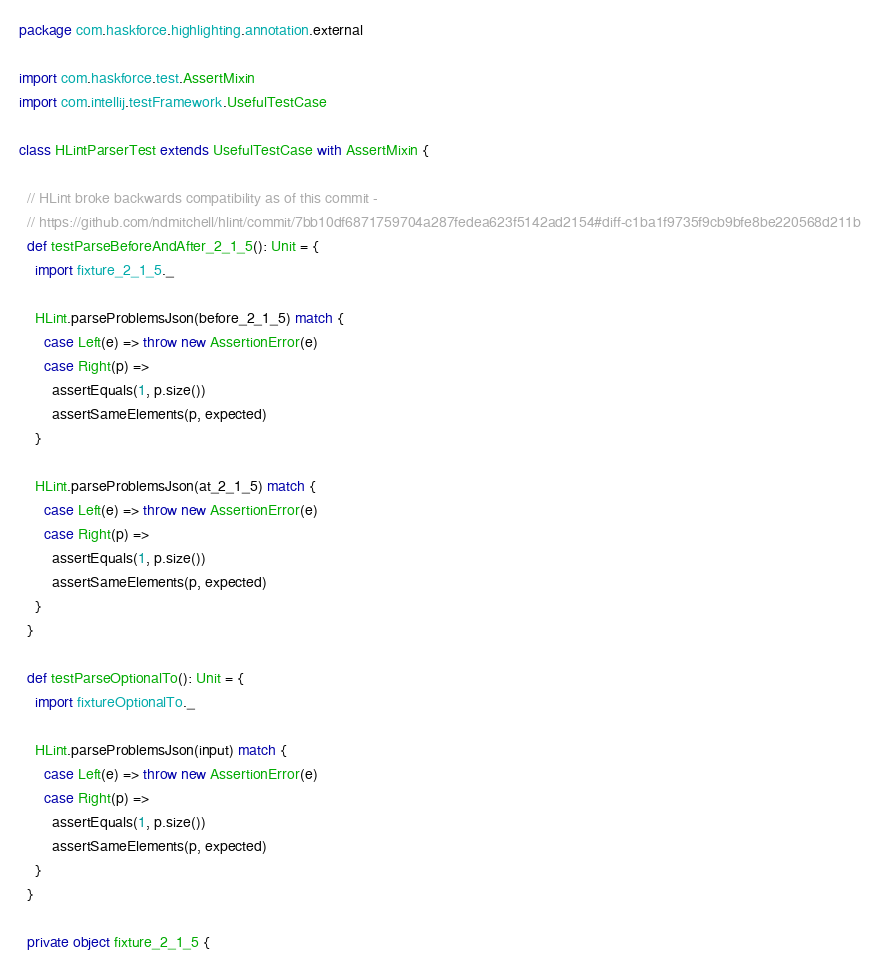<code> <loc_0><loc_0><loc_500><loc_500><_Scala_>package com.haskforce.highlighting.annotation.external

import com.haskforce.test.AssertMixin
import com.intellij.testFramework.UsefulTestCase

class HLintParserTest extends UsefulTestCase with AssertMixin {

  // HLint broke backwards compatibility as of this commit -
  // https://github.com/ndmitchell/hlint/commit/7bb10df6871759704a287fedea623f5142ad2154#diff-c1ba1f9735f9cb9bfe8be220568d211b
  def testParseBeforeAndAfter_2_1_5(): Unit = {
    import fixture_2_1_5._

    HLint.parseProblemsJson(before_2_1_5) match {
      case Left(e) => throw new AssertionError(e)
      case Right(p) =>
        assertEquals(1, p.size())
        assertSameElements(p, expected)
    }

    HLint.parseProblemsJson(at_2_1_5) match {
      case Left(e) => throw new AssertionError(e)
      case Right(p) =>
        assertEquals(1, p.size())
        assertSameElements(p, expected)
    }
  }

  def testParseOptionalTo(): Unit = {
    import fixtureOptionalTo._

    HLint.parseProblemsJson(input) match {
      case Left(e) => throw new AssertionError(e)
      case Right(p) =>
        assertEquals(1, p.size())
        assertSameElements(p, expected)
    }
  }

  private object fixture_2_1_5 {</code> 